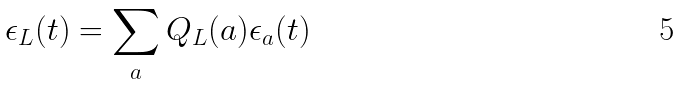<formula> <loc_0><loc_0><loc_500><loc_500>\epsilon _ { L } ( t ) = \sum _ { a } Q _ { L } ( a ) \epsilon _ { a } ( t )</formula> 